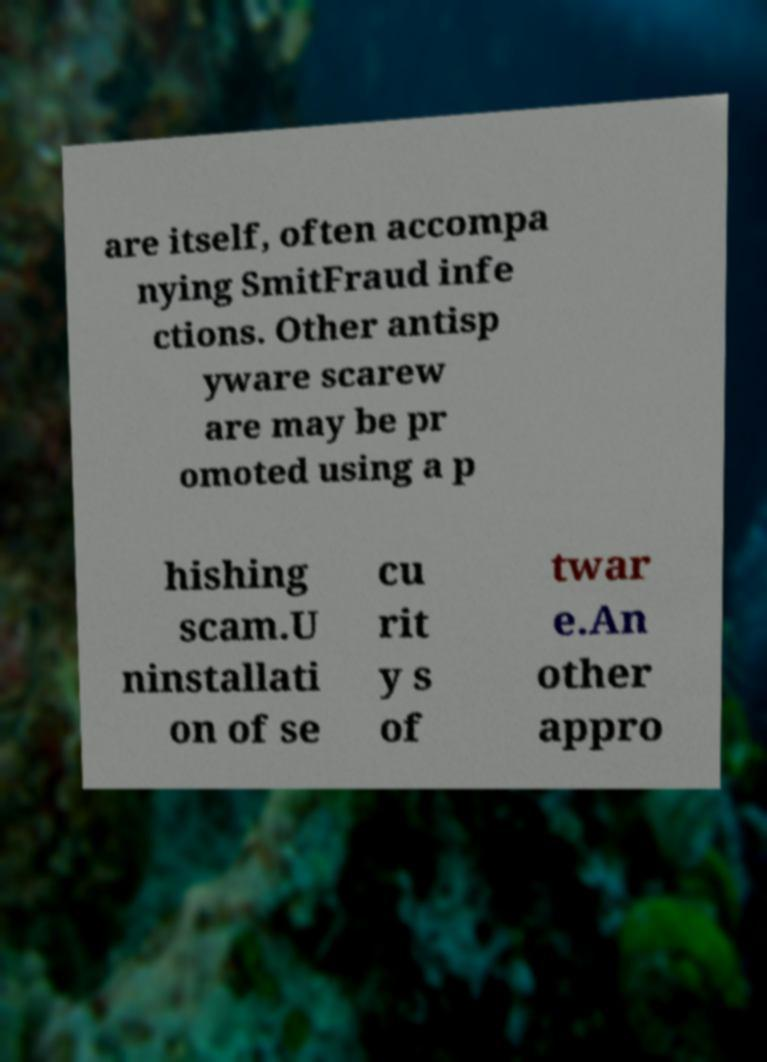Please read and relay the text visible in this image. What does it say? are itself, often accompa nying SmitFraud infe ctions. Other antisp yware scarew are may be pr omoted using a p hishing scam.U ninstallati on of se cu rit y s of twar e.An other appro 